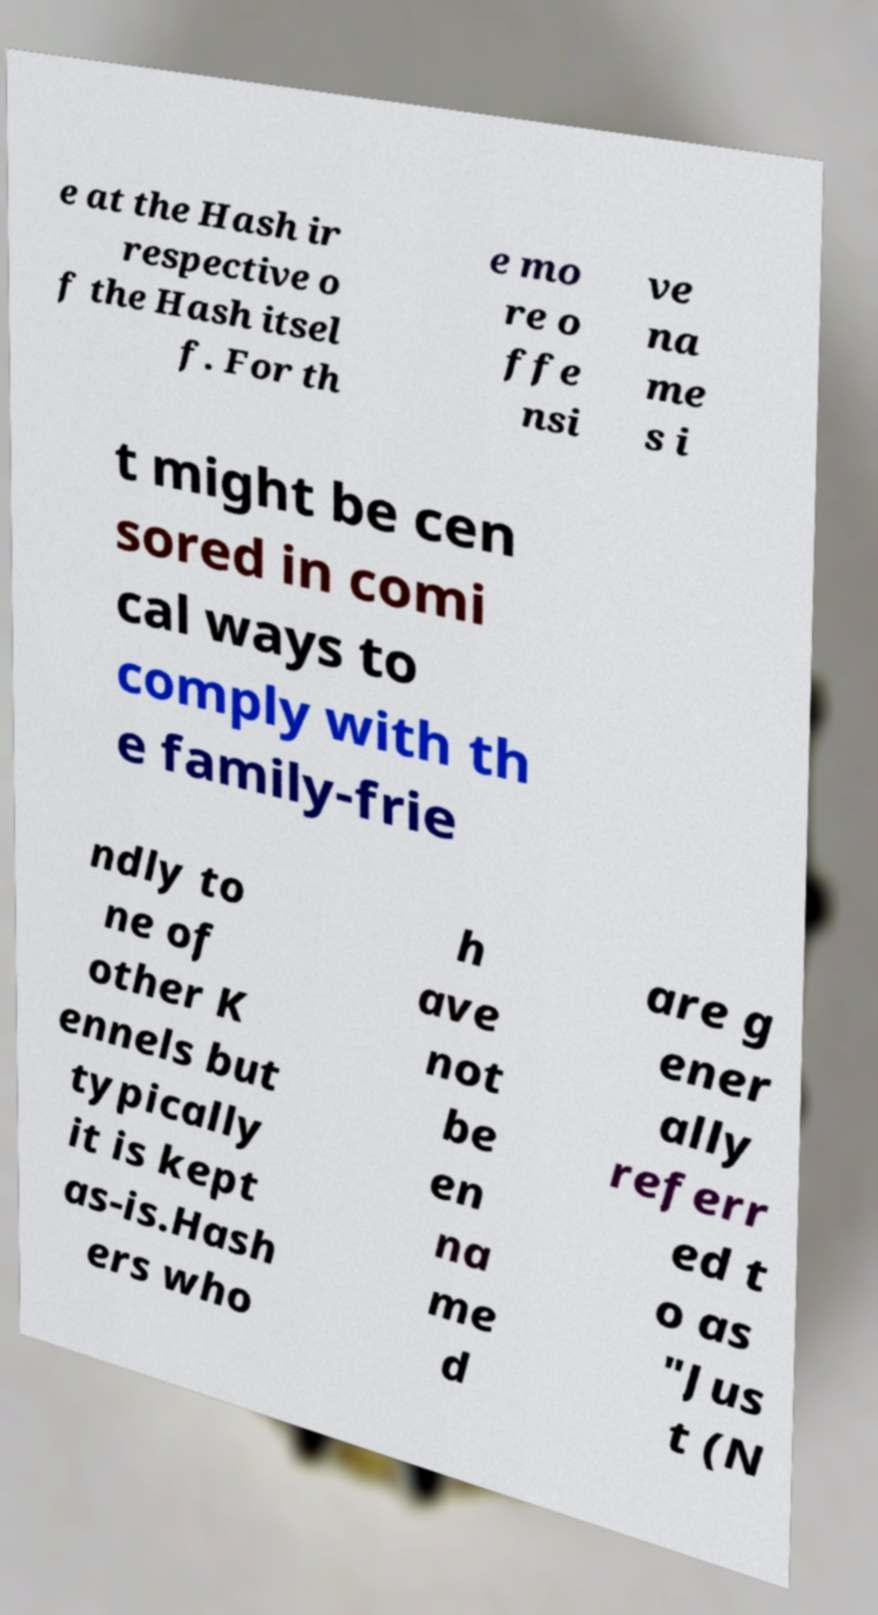I need the written content from this picture converted into text. Can you do that? e at the Hash ir respective o f the Hash itsel f. For th e mo re o ffe nsi ve na me s i t might be cen sored in comi cal ways to comply with th e family-frie ndly to ne of other K ennels but typically it is kept as-is.Hash ers who h ave not be en na me d are g ener ally referr ed t o as "Jus t (N 